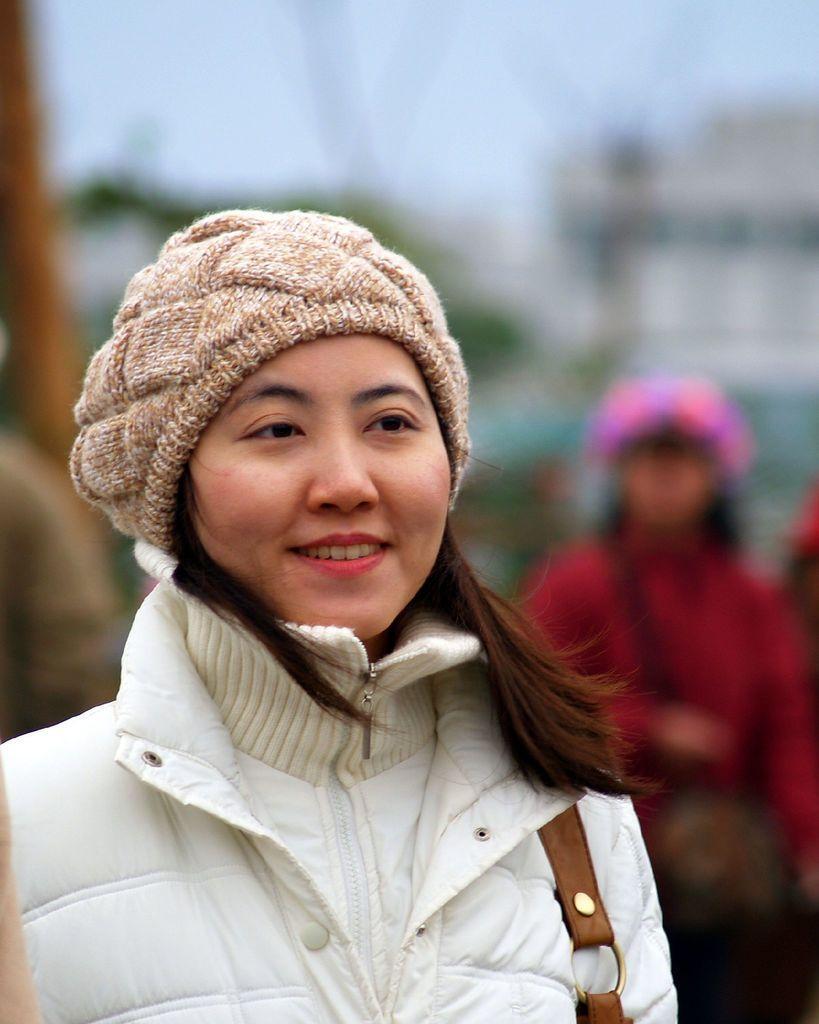Could you give a brief overview of what you see in this image? In the image we can see a woman standing and smiling. Behind her few people are standing. Background of the image is blur. 